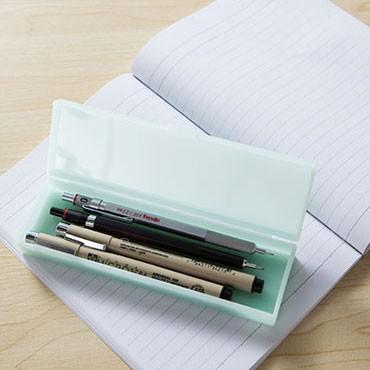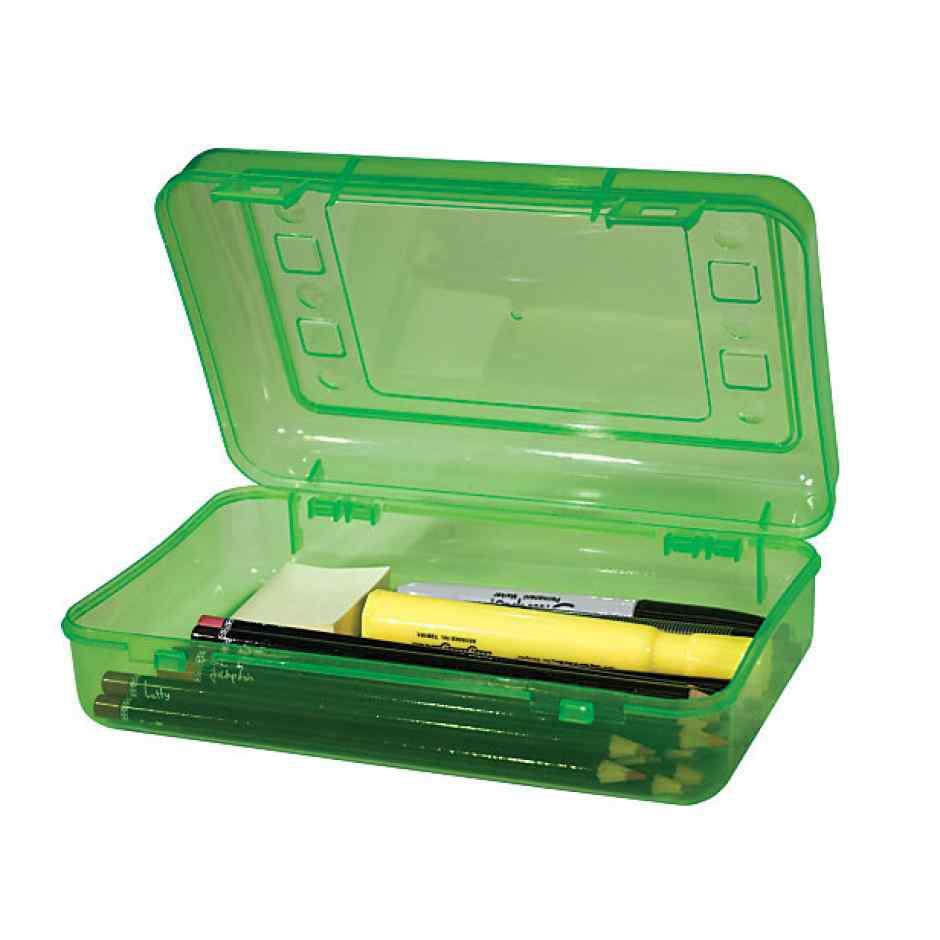The first image is the image on the left, the second image is the image on the right. Given the left and right images, does the statement "The pencil cases are open." hold true? Answer yes or no. Yes. The first image is the image on the left, the second image is the image on the right. Assess this claim about the two images: "Each image includes an open plastic rectangular case filled with supplies, and at least one of the open cases pictured is greenish.". Correct or not? Answer yes or no. Yes. 